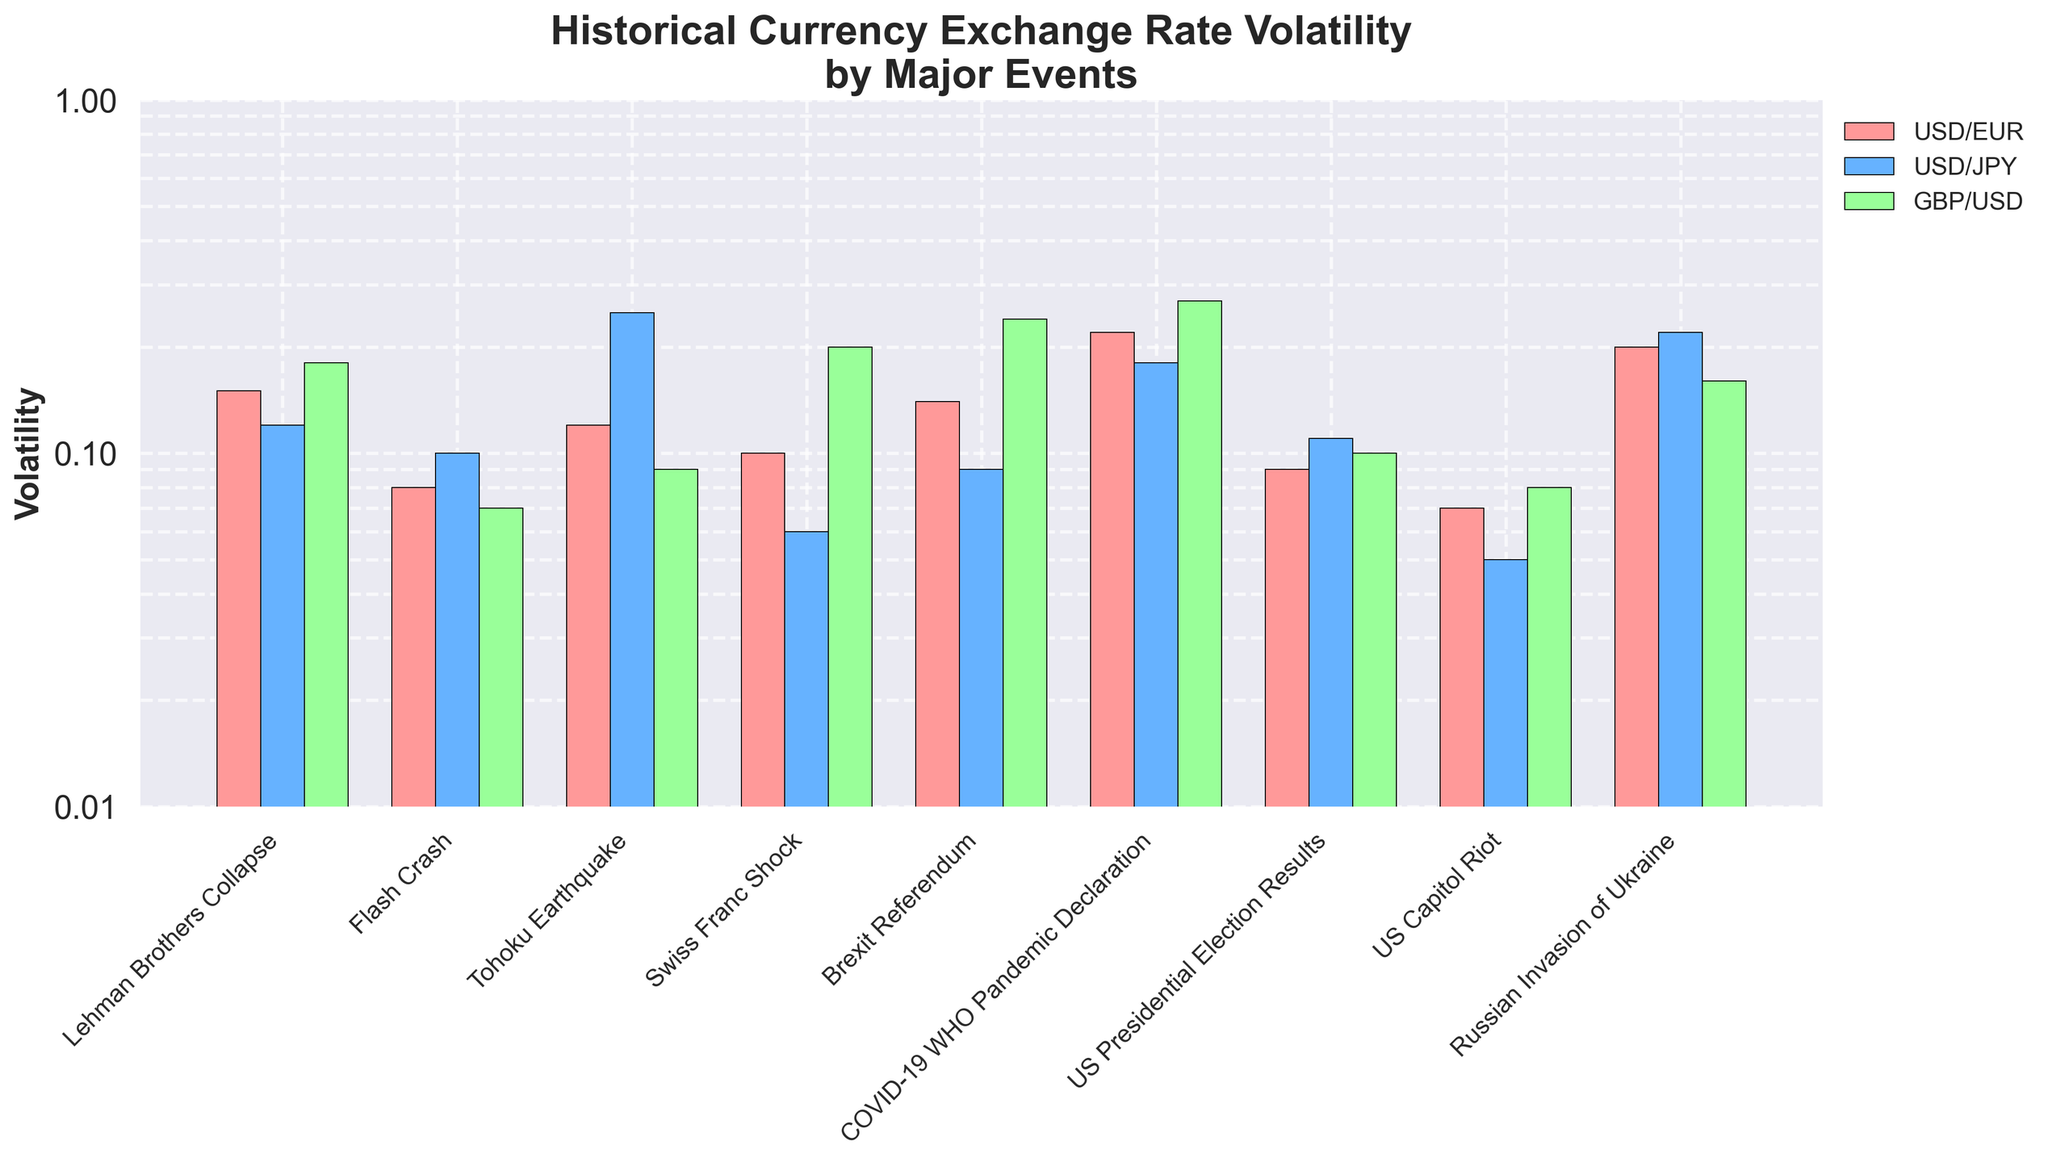What is the title of the figure? The title is prominently displayed at the top of the figure. It reads "Historical Currency Exchange Rate Volatility by Major Events".
Answer: Historical Currency Exchange Rate Volatility by Major Events How many major events are detailed in the figure? By counting the x-axis labels or the bars grouped by events, we can see there are nine major events depicted in the figure.
Answer: 9 What is the highest volatility value for USD/EUR and during which event did it occur? By looking at the bars representing USD/EUR, the highest volatility value can be identified (0.22), and it occurred during the "COVID-19 WHO Pandemic Declaration" event.
Answer: 0.22 during the "COVID-19 WHO Pandemic Declaration" Which event caused the highest volatility in GBP/USD? We need to identify the highest bar for GBP/USD. The "COVID-19 WHO Pandemic Declaration" has the highest value (0.27).
Answer: COVID-19 WHO Pandemic Declaration During which event is the USD/JPY volatility the lowest, and what is its value? By analyzing the heights of the bars for USD/JPY, the lowest volatility value (0.05) occurred during the "US Capitol Riot".
Answer: US Capitol Riot, 0.05 What is the average volatility of USD/EUR during the last three events? First, identify the three latest events: "US Presidential Election Results", "US Capitol Riot", and "Russian Invasion of Ukraine". Then, sum their volatilities (0.09 + 0.07 + 0.20 = 0.36) and divide by 3 (0.36 / 3 = 0.12).
Answer: 0.12 Which currency pair had the most significant increase in volatility from the "US Presidential Election Results" to the "Russian Invasion of Ukraine"? Calculate the difference for each currency pair between these two events: 
- USD/EUR: 0.20 - 0.09 = 0.11
- USD/JPY: 0.22 - 0.11 = 0.11 
- GBP/USD: 0.16 - 0.10 = 0.06 
USD/EUR and USD/JPY had the same greatest increase (0.11).
Answer: USD/EUR and USD/JPY, both with an increase of 0.11 Which event had nearly equal volatilities between USD/JPY and GBP/USD? We need to find the event where the bars for USD/JPY and GBP/USD have similar heights. The "Russian Invasion of Ukraine" event shows nearly equal volatility (0.22 for USD/JPY and 0.16 for GBP/USD).
Answer: Russian Invasion of Ukraine How does the volatility during the "Lehman Brothers Collapse" compare for the three currency pairs? Check the bar heights at the "Lehman Brothers Collapse" event:
- USD/EUR: 0.15
- USD/JPY: 0.12
- GBP/USD: 0.18
GBP/USD had the highest volatility, followed by USD/EUR and USD/JPY.
Answer: GBP/USD > USD/EUR > USD/JPY 